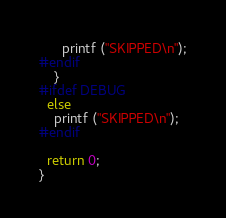Convert code to text. <code><loc_0><loc_0><loc_500><loc_500><_C_>      printf ("SKIPPED\n");
#endif
    }
#ifdef DEBUG
  else
    printf ("SKIPPED\n");
#endif

  return 0;
}
</code> 